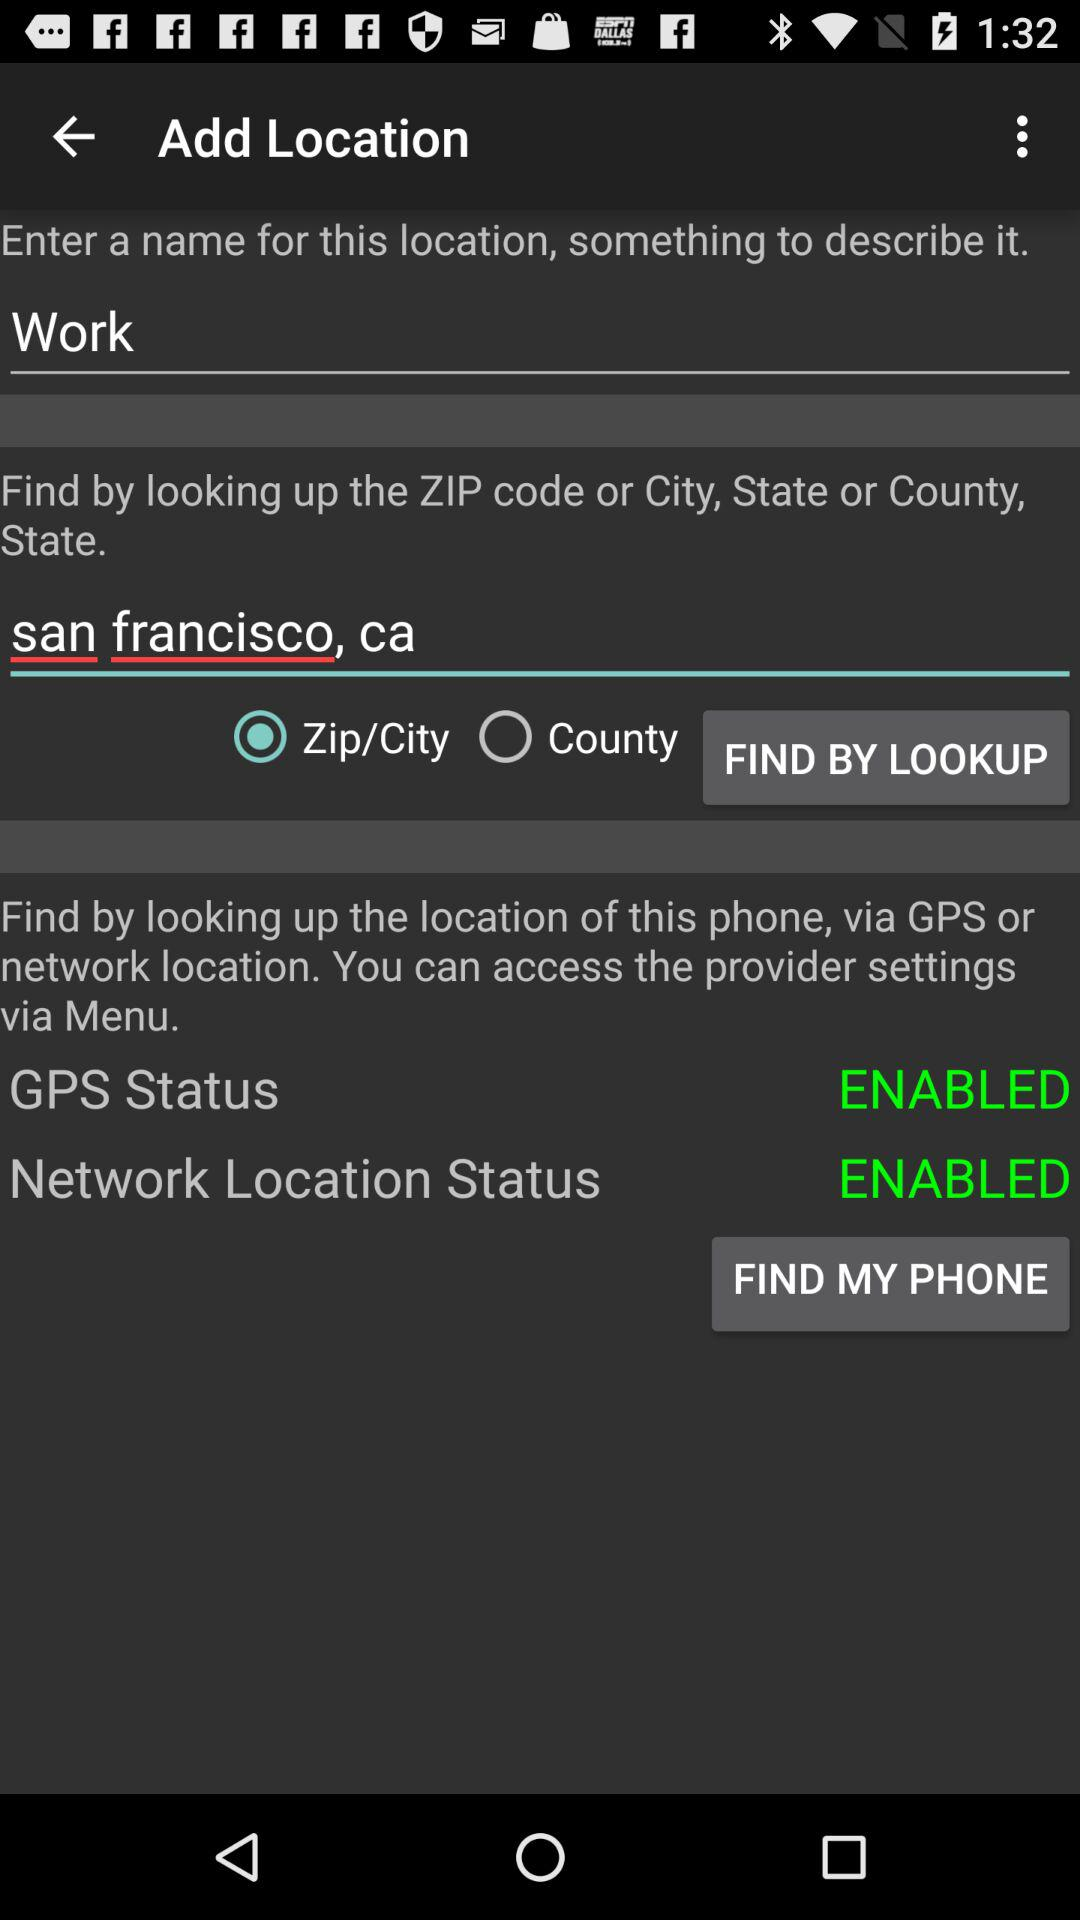What city is shown on the screen? The city is San Francisco, CA. 